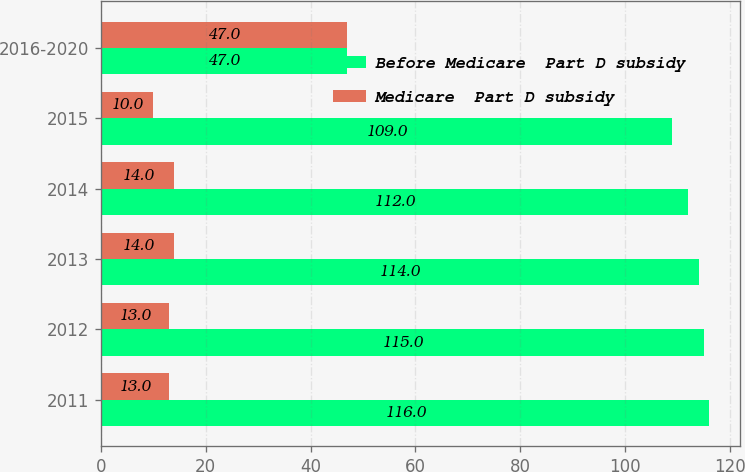Convert chart to OTSL. <chart><loc_0><loc_0><loc_500><loc_500><stacked_bar_chart><ecel><fcel>2011<fcel>2012<fcel>2013<fcel>2014<fcel>2015<fcel>2016-2020<nl><fcel>Before Medicare  Part D subsidy<fcel>116<fcel>115<fcel>114<fcel>112<fcel>109<fcel>47<nl><fcel>Medicare  Part D subsidy<fcel>13<fcel>13<fcel>14<fcel>14<fcel>10<fcel>47<nl></chart> 